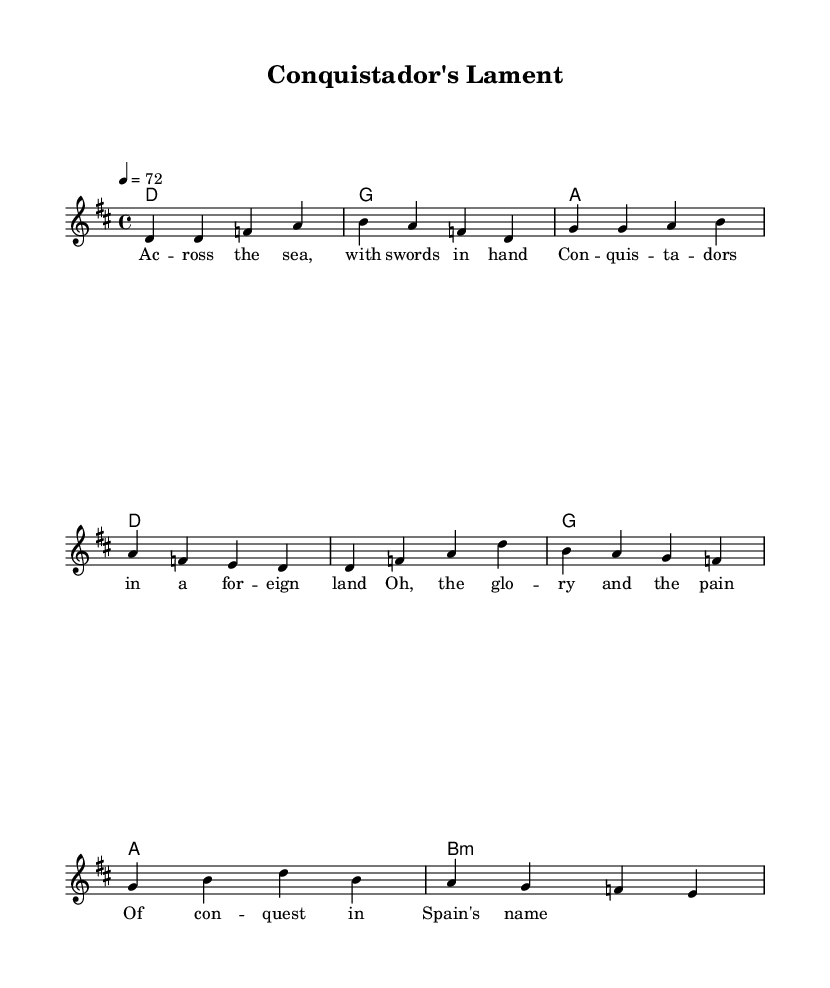What is the key signature of this music? The key signature is indicated by the presence of two sharps on the staff, which denotes D major.
Answer: D major What is the time signature of this music? The time signature is indicated at the beginning of the sheet music as 4/4, meaning there are four beats in each measure.
Answer: 4/4 What is the tempo marking for this piece? The tempo marking specifies that the piece should be played at a speed of 72 beats per minute, indicated as "4 = 72."
Answer: 72 How many measures are in the verse section? The verse section contains a total of four measures based on visual counts of the music notation provided.
Answer: 4 measures What are the first two notes of the chorus? The first two notes of the chorus are D and F, as shown in the melody section of the sheet music.
Answer: D, F How many chords are used in the verse? The verse contains four distinct chords as indicated in the chord mode section: D, G, A, and D.
Answer: 4 chords What thematic concept is represented in the lyrics? The lyrics express the idea of conquest and the complexities surrounding it, particularly focusing on glory and pain associated with the actions of conquistadors.
Answer: Conquest theme 